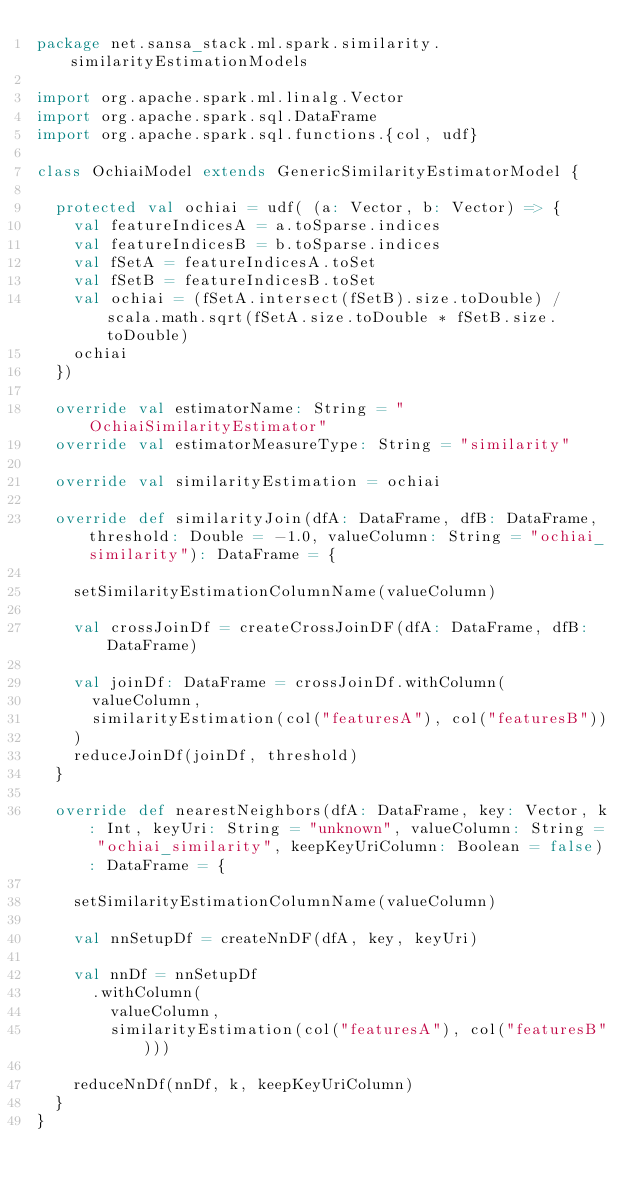<code> <loc_0><loc_0><loc_500><loc_500><_Scala_>package net.sansa_stack.ml.spark.similarity.similarityEstimationModels

import org.apache.spark.ml.linalg.Vector
import org.apache.spark.sql.DataFrame
import org.apache.spark.sql.functions.{col, udf}

class OchiaiModel extends GenericSimilarityEstimatorModel {

  protected val ochiai = udf( (a: Vector, b: Vector) => {
    val featureIndicesA = a.toSparse.indices
    val featureIndicesB = b.toSparse.indices
    val fSetA = featureIndicesA.toSet
    val fSetB = featureIndicesB.toSet
    val ochiai = (fSetA.intersect(fSetB).size.toDouble) / scala.math.sqrt(fSetA.size.toDouble * fSetB.size.toDouble)
    ochiai
  })

  override val estimatorName: String = "OchiaiSimilarityEstimator"
  override val estimatorMeasureType: String = "similarity"

  override val similarityEstimation = ochiai

  override def similarityJoin(dfA: DataFrame, dfB: DataFrame, threshold: Double = -1.0, valueColumn: String = "ochiai_similarity"): DataFrame = {

    setSimilarityEstimationColumnName(valueColumn)

    val crossJoinDf = createCrossJoinDF(dfA: DataFrame, dfB: DataFrame)

    val joinDf: DataFrame = crossJoinDf.withColumn(
      valueColumn,
      similarityEstimation(col("featuresA"), col("featuresB"))
    )
    reduceJoinDf(joinDf, threshold)
  }

  override def nearestNeighbors(dfA: DataFrame, key: Vector, k: Int, keyUri: String = "unknown", valueColumn: String = "ochiai_similarity", keepKeyUriColumn: Boolean = false): DataFrame = {

    setSimilarityEstimationColumnName(valueColumn)

    val nnSetupDf = createNnDF(dfA, key, keyUri)

    val nnDf = nnSetupDf
      .withColumn(
        valueColumn,
        similarityEstimation(col("featuresA"), col("featuresB")))

    reduceNnDf(nnDf, k, keepKeyUriColumn)
  }
}
</code> 